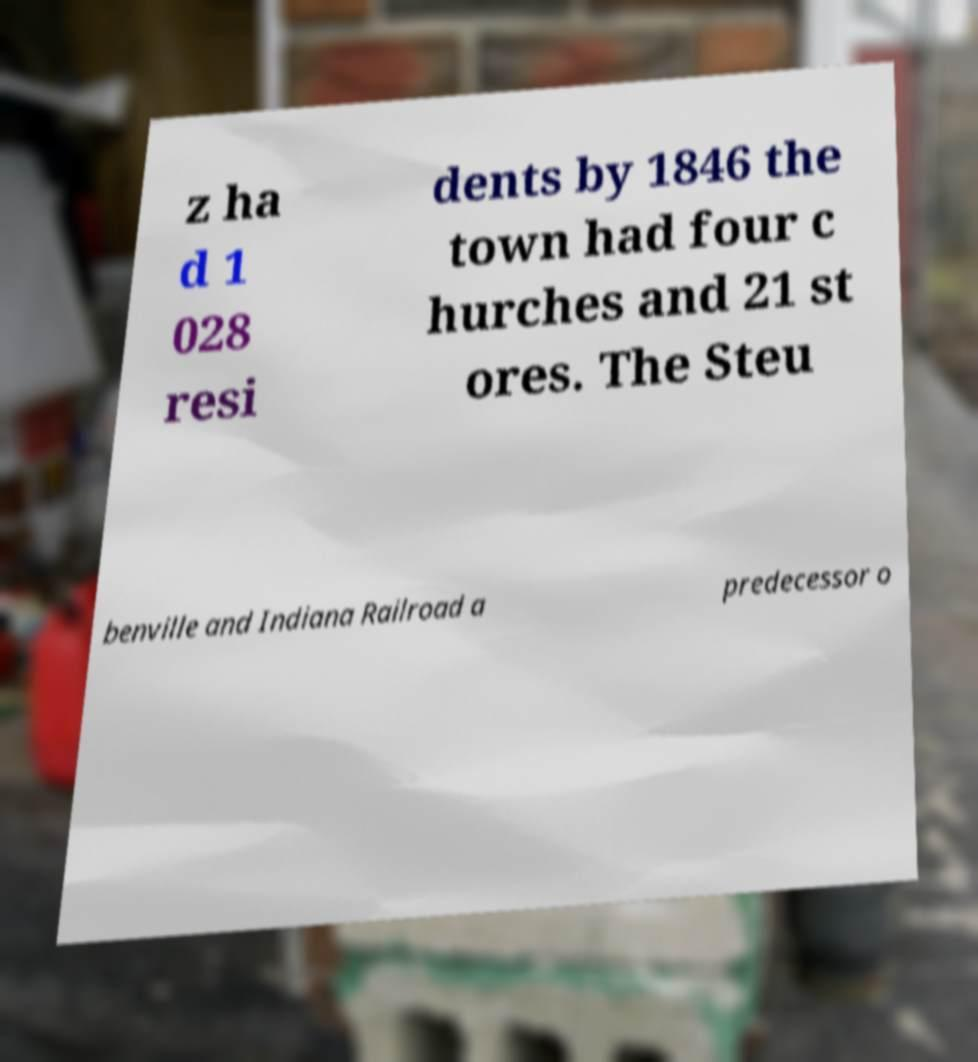I need the written content from this picture converted into text. Can you do that? z ha d 1 028 resi dents by 1846 the town had four c hurches and 21 st ores. The Steu benville and Indiana Railroad a predecessor o 